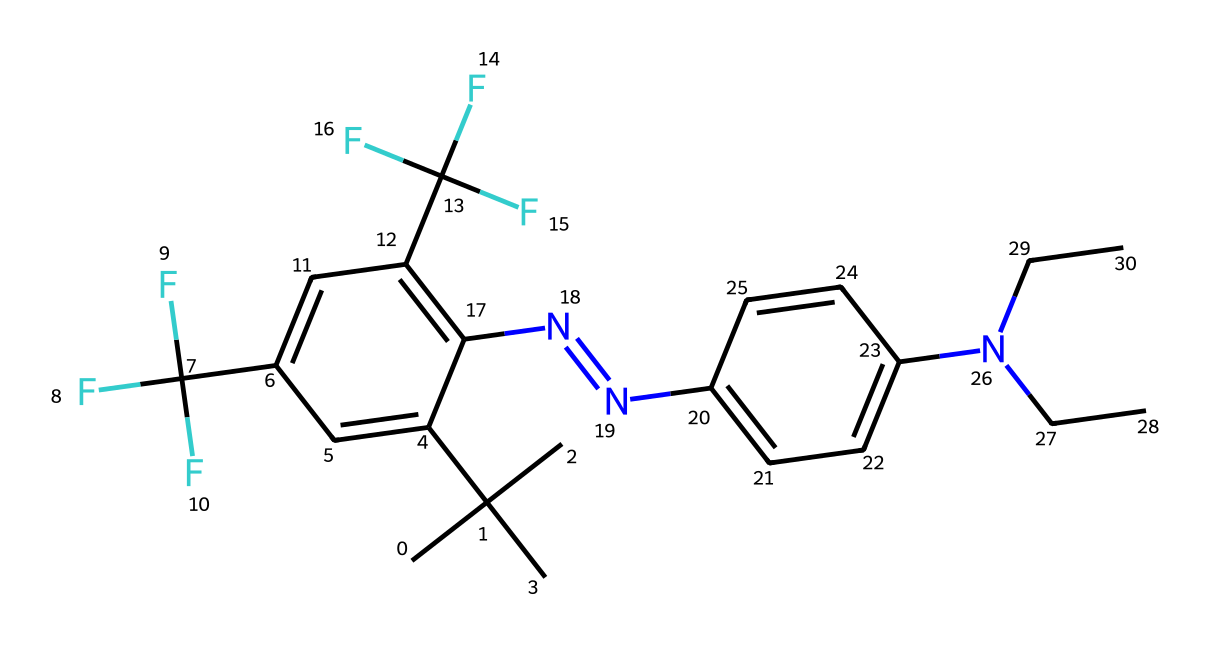What is the molecular formula of this chemical? To determine the molecular formula, identify the number of each type of atom present in the structure. The SMILES representation indicates that it contains carbon, hydrogen, nitrogen, and fluorine atoms. By counting, we find there are 16 carbons, 19 hydrogens, 4 fluorine, and 2 nitrogens. Therefore, the molecular formula is C16H19F4N2.
Answer: C16H19F4N2 How many nitrogen atoms are present in this structure? The SMILES representation includes two occurrences of 'N', indicating the presence of nitrogen atoms. Counting these gives a total of 2 nitrogen atoms.
Answer: 2 What type of functional groups are indicated by the Fluorine atoms? The presence of fluorinated groups (C(F)(F)F) suggests that there are trifluoromethyl groups connected to the aromatic ring in this structure, which are characteristic of certain halocarbon compounds. This gives the chemical unique properties relating to color and stability.
Answer: trifluoromethyl groups Does this chemical contain any double bonds? In the SMILES representation, the "=" sign indicates the presence of at least one double bond, while examining the structure reveals that the azo (-N=N-) bond signifies the presence of a double bond. Therefore, yes, this chemical contains double bonds.
Answer: yes What effect might the fluorine atoms have on the pigment's properties? The introduction of fluorine atoms typically enhances the stability and vibrancy of pigments. Fluorine's electronegativity and small size create strong bonds which contribute to the stability of color under light exposure and environmental conditions. Thus, as a result, fluorinated pigments are often more vibrant.
Answer: enhanced stability and vibrancy What is the overall charge of this molecule? Analyzing the structure, there are no ions, and it appears that all the atoms are neutral. Therefore, the overall charge of the molecule is zero.
Answer: zero How many aromatic rings are present in this compound? By visualizing the SMILES representation, the structure contains two distinct aromatic rings, one for each benzene-like portion of the backbone. Each aromatic part are connected via the azo linkage. Thus, there are two aromatic rings present.
Answer: 2 